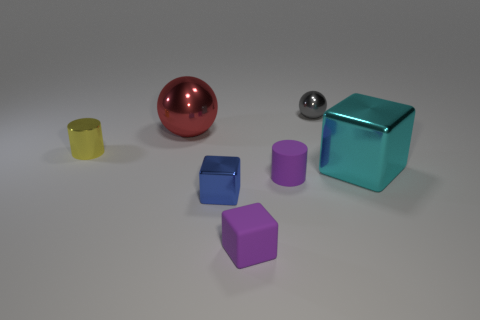What is the size of the metallic cylinder in front of the metallic ball right of the small matte cylinder?
Give a very brief answer. Small. There is a metallic block in front of the cyan block; does it have the same size as the metallic cylinder?
Give a very brief answer. Yes. Is the number of small blue blocks that are behind the gray object greater than the number of big things behind the big cyan metallic object?
Provide a succinct answer. No. What shape is the shiny thing that is both behind the yellow thing and on the left side of the small blue metallic cube?
Offer a very short reply. Sphere. What is the shape of the tiny shiny thing to the right of the matte cylinder?
Ensure brevity in your answer.  Sphere. There is a ball left of the tiny cube that is on the right side of the shiny cube left of the gray object; what is its size?
Your answer should be compact. Large. Is the small gray metal object the same shape as the red object?
Give a very brief answer. Yes. What is the size of the shiny object that is behind the yellow thing and on the left side of the small gray metallic ball?
Make the answer very short. Large. What material is the small purple thing that is the same shape as the small yellow metallic object?
Offer a terse response. Rubber. What is the cylinder that is behind the small cylinder that is right of the small yellow shiny thing made of?
Your response must be concise. Metal. 